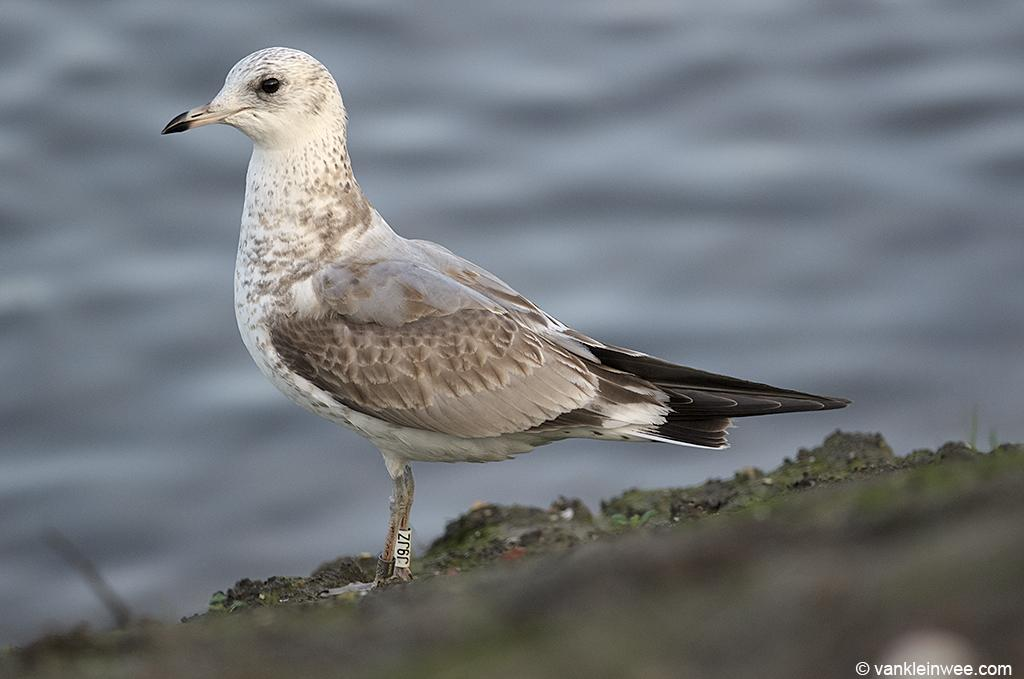What type of animal is in the image? There is a bird in the image. What colors can be seen on the bird? The bird has cream, black, and brown colors. Can you describe the background of the image? The background of the image is blurred. What letters are visible on the tent in the image? There is no tent present in the image, and therefore no letters can be seen on it. 